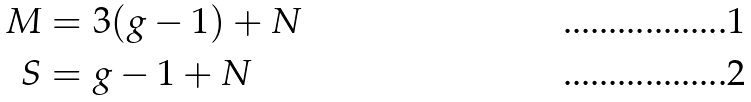Convert formula to latex. <formula><loc_0><loc_0><loc_500><loc_500>M & = 3 ( g - 1 ) + N \\ S & = g - 1 + N</formula> 